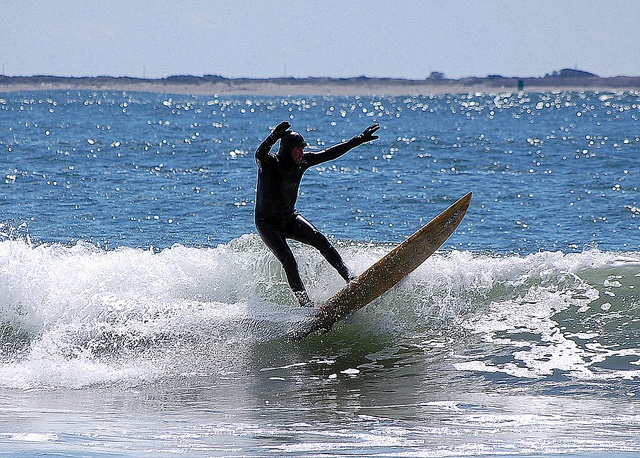Describe the objects in this image and their specific colors. I can see people in lavender, black, gray, lightgray, and darkgray tones and surfboard in lavender, black, and gray tones in this image. 